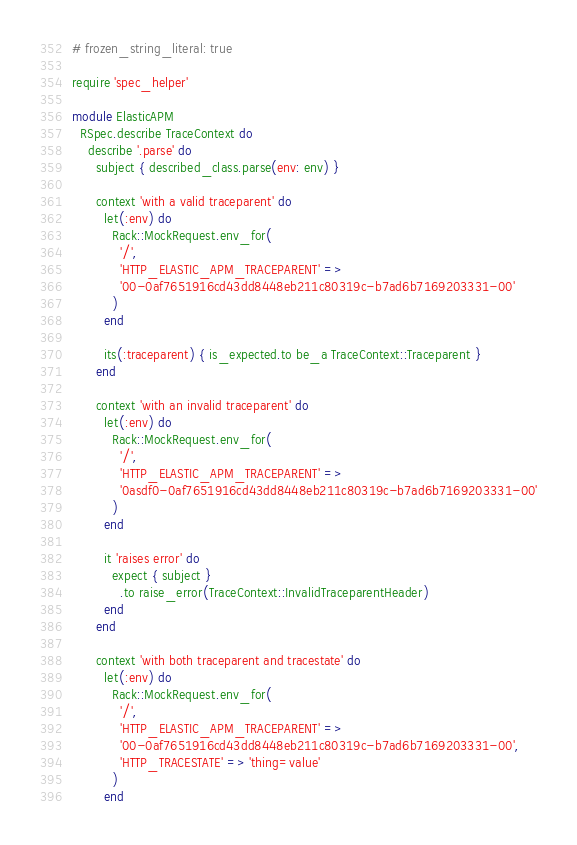<code> <loc_0><loc_0><loc_500><loc_500><_Ruby_># frozen_string_literal: true

require 'spec_helper'

module ElasticAPM
  RSpec.describe TraceContext do
    describe '.parse' do
      subject { described_class.parse(env: env) }

      context 'with a valid traceparent' do
        let(:env) do
          Rack::MockRequest.env_for(
            '/',
            'HTTP_ELASTIC_APM_TRACEPARENT' =>
            '00-0af7651916cd43dd8448eb211c80319c-b7ad6b7169203331-00'
          )
        end

        its(:traceparent) { is_expected.to be_a TraceContext::Traceparent }
      end

      context 'with an invalid traceparent' do
        let(:env) do
          Rack::MockRequest.env_for(
            '/',
            'HTTP_ELASTIC_APM_TRACEPARENT' =>
            '0asdf0-0af7651916cd43dd8448eb211c80319c-b7ad6b7169203331-00'
          )
        end

        it 'raises error' do
          expect { subject }
            .to raise_error(TraceContext::InvalidTraceparentHeader)
        end
      end

      context 'with both traceparent and tracestate' do
        let(:env) do
          Rack::MockRequest.env_for(
            '/',
            'HTTP_ELASTIC_APM_TRACEPARENT' =>
            '00-0af7651916cd43dd8448eb211c80319c-b7ad6b7169203331-00',
            'HTTP_TRACESTATE' => 'thing=value'
          )
        end
</code> 